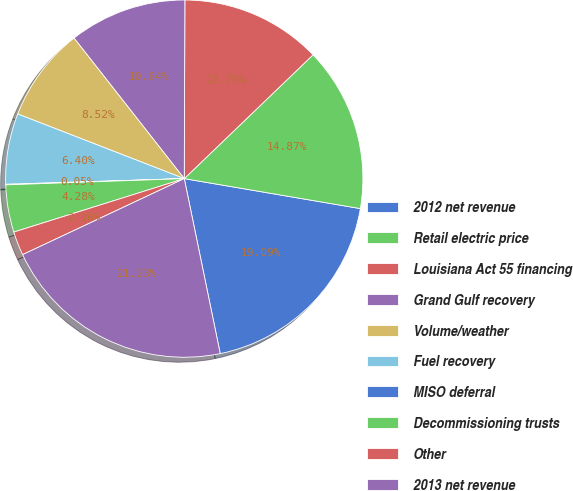<chart> <loc_0><loc_0><loc_500><loc_500><pie_chart><fcel>2012 net revenue<fcel>Retail electric price<fcel>Louisiana Act 55 financing<fcel>Grand Gulf recovery<fcel>Volume/weather<fcel>Fuel recovery<fcel>MISO deferral<fcel>Decommissioning trusts<fcel>Other<fcel>2013 net revenue<nl><fcel>19.09%<fcel>14.87%<fcel>12.76%<fcel>10.64%<fcel>8.52%<fcel>6.4%<fcel>0.05%<fcel>4.28%<fcel>2.16%<fcel>21.23%<nl></chart> 